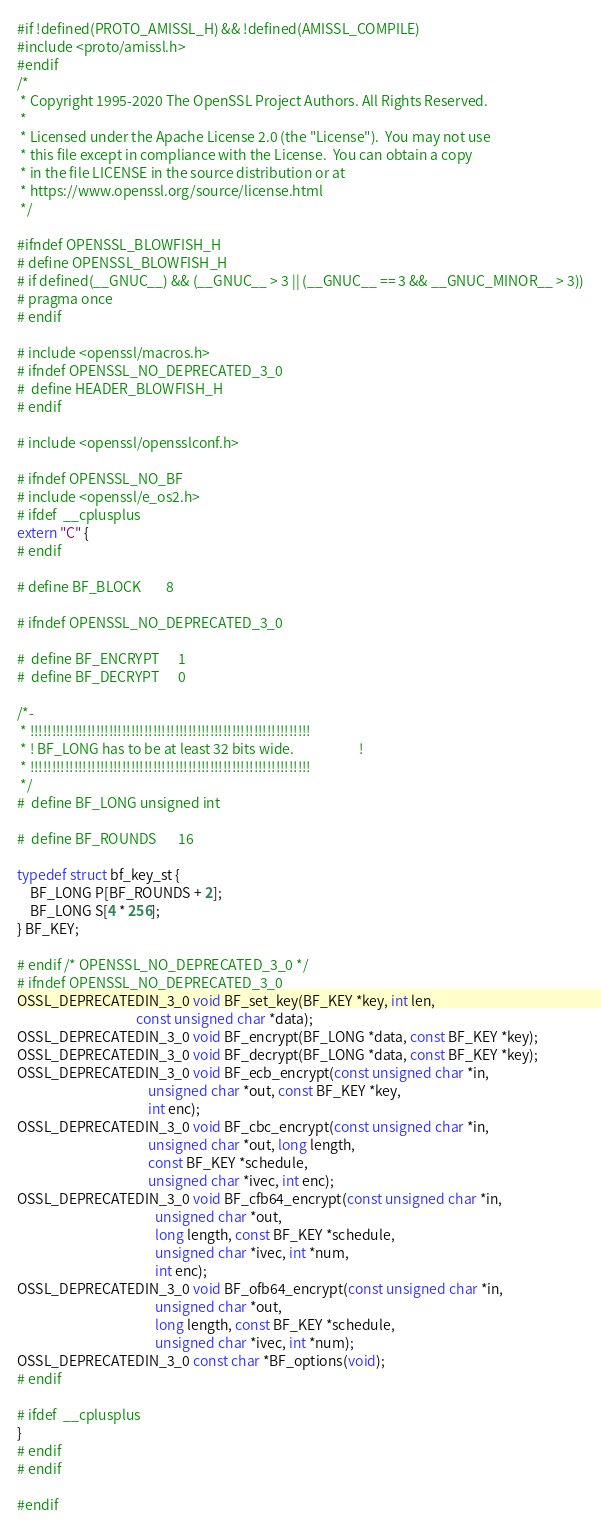<code> <loc_0><loc_0><loc_500><loc_500><_C_>#if !defined(PROTO_AMISSL_H) && !defined(AMISSL_COMPILE)
#include <proto/amissl.h>
#endif
/*
 * Copyright 1995-2020 The OpenSSL Project Authors. All Rights Reserved.
 *
 * Licensed under the Apache License 2.0 (the "License").  You may not use
 * this file except in compliance with the License.  You can obtain a copy
 * in the file LICENSE in the source distribution or at
 * https://www.openssl.org/source/license.html
 */

#ifndef OPENSSL_BLOWFISH_H
# define OPENSSL_BLOWFISH_H
# if defined(__GNUC__) && (__GNUC__ > 3 || (__GNUC__ == 3 && __GNUC_MINOR__ > 3))
# pragma once
# endif

# include <openssl/macros.h>
# ifndef OPENSSL_NO_DEPRECATED_3_0
#  define HEADER_BLOWFISH_H
# endif

# include <openssl/opensslconf.h>

# ifndef OPENSSL_NO_BF
# include <openssl/e_os2.h>
# ifdef  __cplusplus
extern "C" {
# endif

# define BF_BLOCK        8

# ifndef OPENSSL_NO_DEPRECATED_3_0

#  define BF_ENCRYPT      1
#  define BF_DECRYPT      0

/*-
 * !!!!!!!!!!!!!!!!!!!!!!!!!!!!!!!!!!!!!!!!!!!!!!!!!!!!!!!!!!!!!!!!
 * ! BF_LONG has to be at least 32 bits wide.                     !
 * !!!!!!!!!!!!!!!!!!!!!!!!!!!!!!!!!!!!!!!!!!!!!!!!!!!!!!!!!!!!!!!!
 */
#  define BF_LONG unsigned int

#  define BF_ROUNDS       16

typedef struct bf_key_st {
    BF_LONG P[BF_ROUNDS + 2];
    BF_LONG S[4 * 256];
} BF_KEY;

# endif /* OPENSSL_NO_DEPRECATED_3_0 */
# ifndef OPENSSL_NO_DEPRECATED_3_0
OSSL_DEPRECATEDIN_3_0 void BF_set_key(BF_KEY *key, int len,
                                      const unsigned char *data);
OSSL_DEPRECATEDIN_3_0 void BF_encrypt(BF_LONG *data, const BF_KEY *key);
OSSL_DEPRECATEDIN_3_0 void BF_decrypt(BF_LONG *data, const BF_KEY *key);
OSSL_DEPRECATEDIN_3_0 void BF_ecb_encrypt(const unsigned char *in,
                                          unsigned char *out, const BF_KEY *key,
                                          int enc);
OSSL_DEPRECATEDIN_3_0 void BF_cbc_encrypt(const unsigned char *in,
                                          unsigned char *out, long length,
                                          const BF_KEY *schedule,
                                          unsigned char *ivec, int enc);
OSSL_DEPRECATEDIN_3_0 void BF_cfb64_encrypt(const unsigned char *in,
                                            unsigned char *out,
                                            long length, const BF_KEY *schedule,
                                            unsigned char *ivec, int *num,
                                            int enc);
OSSL_DEPRECATEDIN_3_0 void BF_ofb64_encrypt(const unsigned char *in,
                                            unsigned char *out,
                                            long length, const BF_KEY *schedule,
                                            unsigned char *ivec, int *num);
OSSL_DEPRECATEDIN_3_0 const char *BF_options(void);
# endif

# ifdef  __cplusplus
}
# endif
# endif

#endif
</code> 